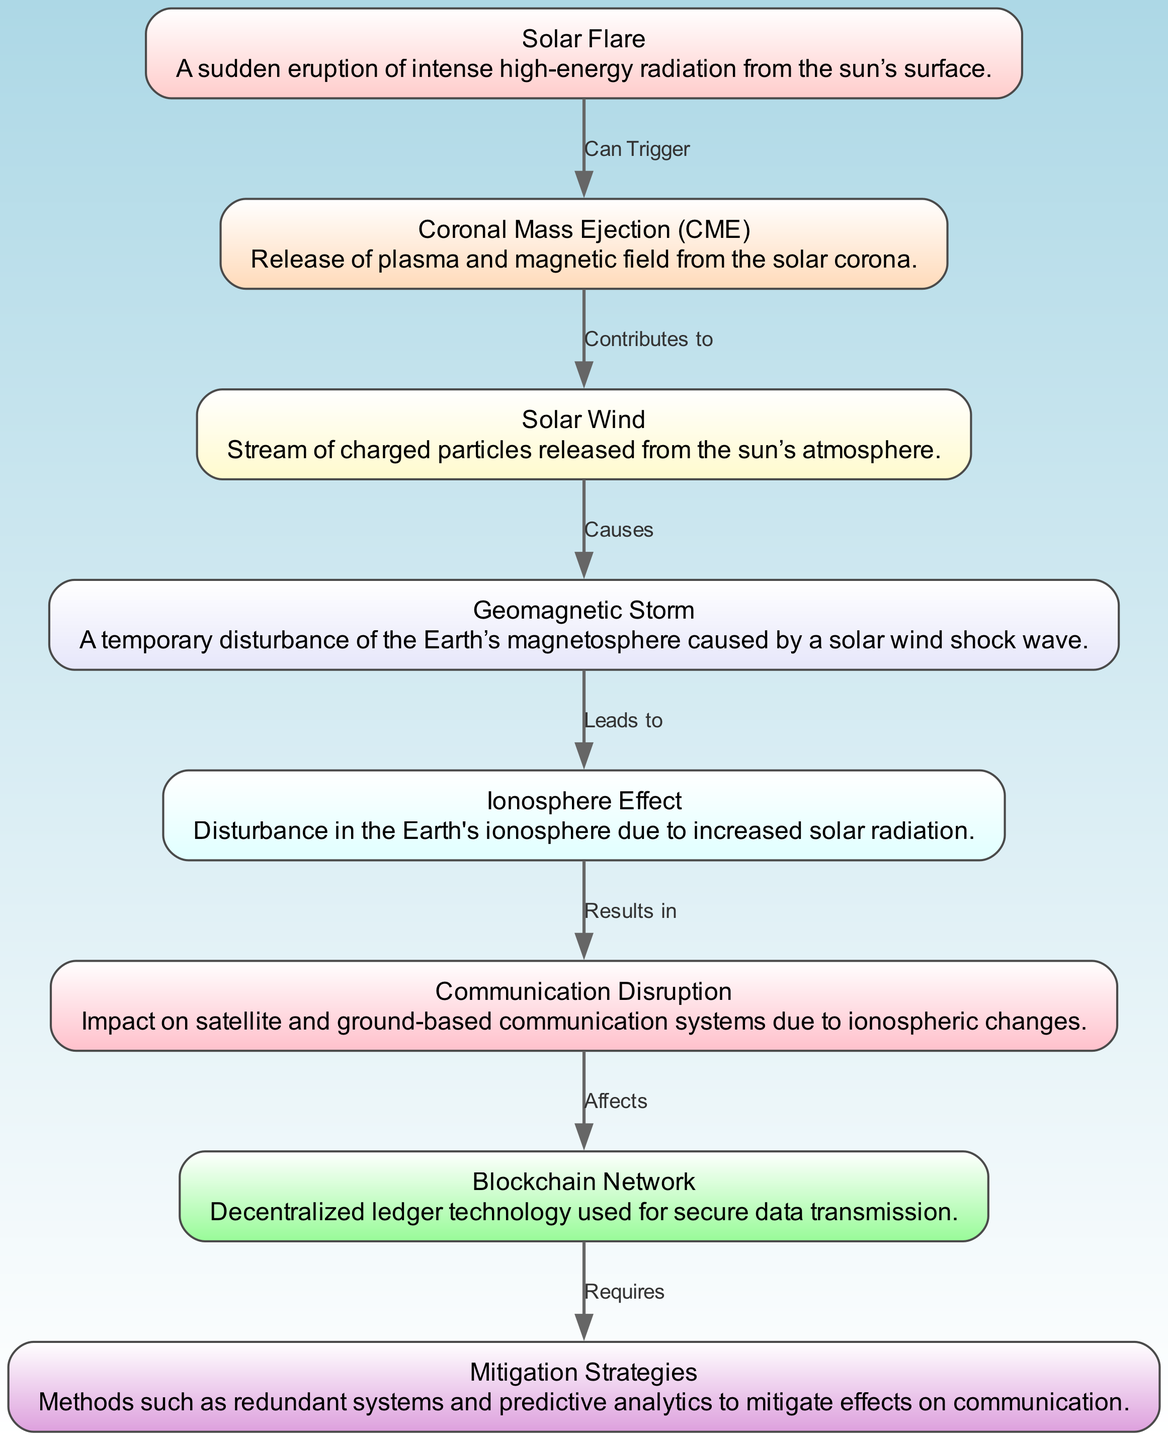What is the first event in the lifecycle? The first event in the lifecycle as depicted in the diagram is "Solar Flare". This is indicated by the positioning of the nodes, where "Solar Flare" is at the topmost part of the diagram, suggesting it starts the sequence.
Answer: Solar Flare How many nodes are present in the diagram? The diagram contains a total of 8 nodes. By counting each individual node listed in the data provided (solar flare, coronal mass ejection, solar wind, geomagnetic storm, ionosphere effect, communication disruption, blockchain network, and mitigation strategies), we can determine the total.
Answer: 8 What is the relationship between "Coronal Mass Ejection (CME)" and "Solar Wind"? The relationship is that "Coronal Mass Ejection (CME)" contributes to "Solar Wind". This is shown by the directed edge in the diagram connecting these two nodes, labeled with the word "Contributes to".
Answer: Contributes to Which node leads to "Ionosphere Effect"? The node that leads to "Ionosphere Effect" is "Geomagnetic Storm". This is established by examining the arrows in the diagram, which indicates the flow from "Geomagnetic Storm" to "Ionosphere Effect".
Answer: Geomagnetic Storm What effect does "Ionosphere Effect" have on communication systems? The effect of "Ionosphere Effect" on communication systems is "Results in Communication Disruption". This connection is clearly defined in the diagram by the arrow leading from "Ionosphere Effect" to "Communication Disruption", labeled "Results in".
Answer: Results in Communication Disruption How does "Communication Disruption" impact blockchain technology? "Communication Disruption" affects "Blockchain Network". The diagram shows a direct relationship illustrated by the arrow pointing from "Communication Disruption" to "Blockchain Network", indicating the impact of the disruption.
Answer: Affects What strategies are indicated to mitigate the effects on the blockchain network? The strategies indicated are "Mitigation Strategies". Looking at the diagram, there is a node named "Mitigation Strategies", connected to the "Blockchain Network" node, showing the connection that implies the need for these strategies to address issues on the network.
Answer: Mitigation Strategies In the lifecycle, which node causes geomagnetic storms? The node that causes geomagnetic storms is "Solar Wind". This can be understood by tracing the directed edge from "Solar Wind" to "Geomagnetic Storm", labeled "Causes", thus establishing the cause-and-effect relationship.
Answer: Causes 